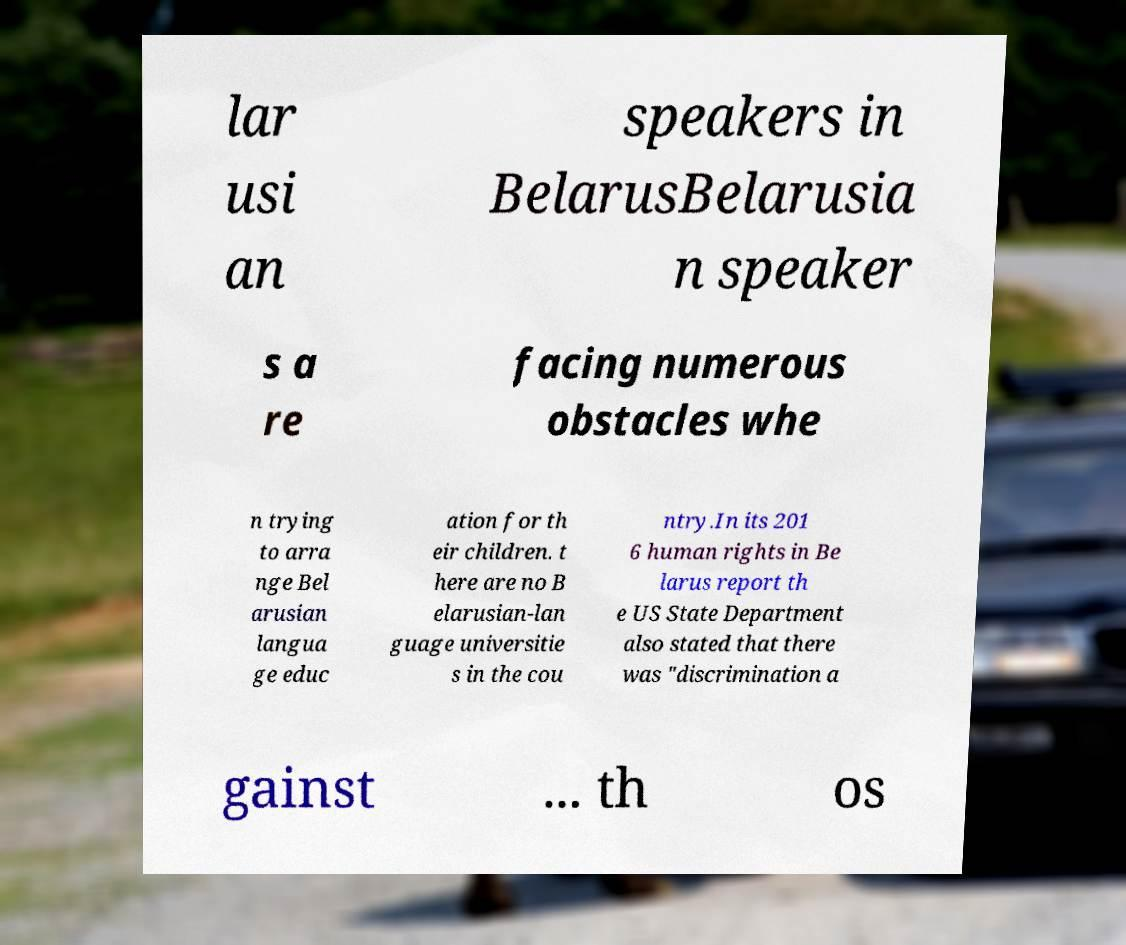Can you read and provide the text displayed in the image?This photo seems to have some interesting text. Can you extract and type it out for me? lar usi an speakers in BelarusBelarusia n speaker s a re facing numerous obstacles whe n trying to arra nge Bel arusian langua ge educ ation for th eir children. t here are no B elarusian-lan guage universitie s in the cou ntry.In its 201 6 human rights in Be larus report th e US State Department also stated that there was "discrimination a gainst ... th os 